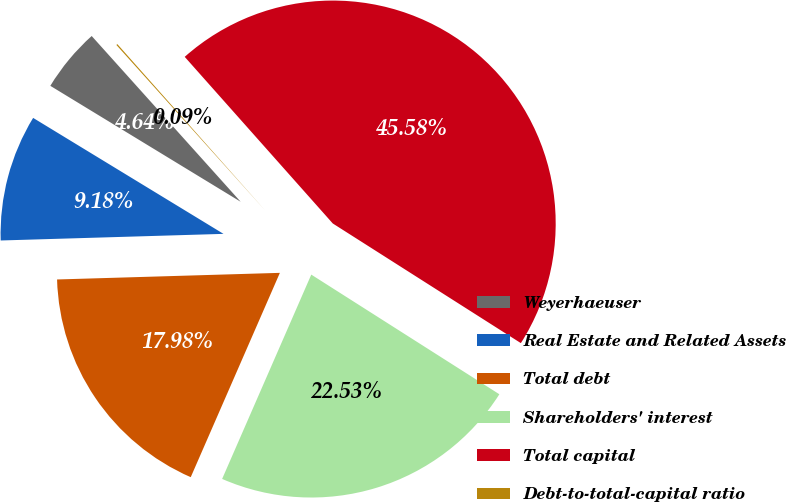Convert chart to OTSL. <chart><loc_0><loc_0><loc_500><loc_500><pie_chart><fcel>Weyerhaeuser<fcel>Real Estate and Related Assets<fcel>Total debt<fcel>Shareholders' interest<fcel>Total capital<fcel>Debt-to-total-capital ratio<nl><fcel>4.64%<fcel>9.18%<fcel>17.98%<fcel>22.53%<fcel>45.58%<fcel>0.09%<nl></chart> 